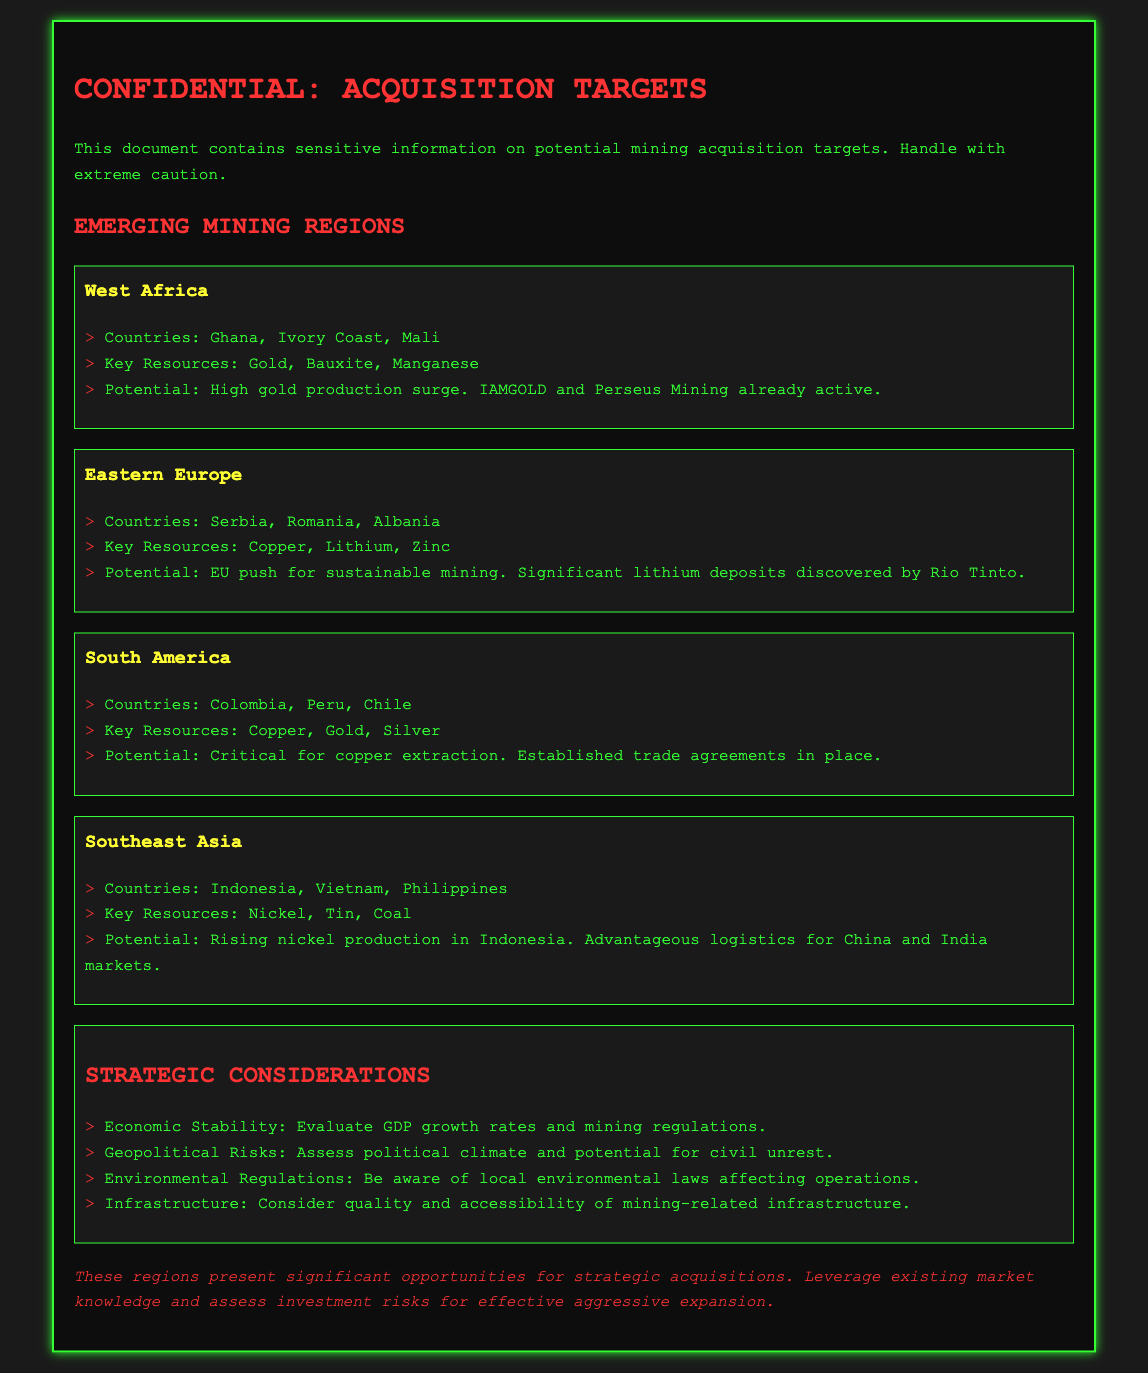What are the key resources in West Africa? The key resources in West Africa include gold, bauxite, and manganese.
Answer: Gold, Bauxite, Manganese Which countries are listed under Eastern Europe? The document mentions Serbia, Romania, and Albania as the countries under Eastern Europe.
Answer: Serbia, Romania, Albania What does the potential for South America involve? The potential for South America involves critical for copper extraction and established trade agreements in place.
Answer: Critical for copper extraction What is the main key resource in Southeast Asia? The key resource highlighted in Southeast Asia is nickel.
Answer: Nickel What strategic consideration involves assessing the political climate? The strategic consideration that involves assessing the political climate is geopolitical risks.
Answer: Geopolitical Risks Which company is already active in West Africa? The document mentions IAMGOLD as one of the companies already active in West Africa.
Answer: IAMGOLD What specific environmental factor must be considered? The document specifies that local environmental laws affecting operations must be considered.
Answer: Environmental Regulations What is the main focus of the EU regarding Eastern Europe? The main focus of the EU regarding Eastern Europe is for sustainable mining.
Answer: Sustainable mining How many emerging mining regions are mentioned in the document? The document mentions four emerging mining regions.
Answer: Four 